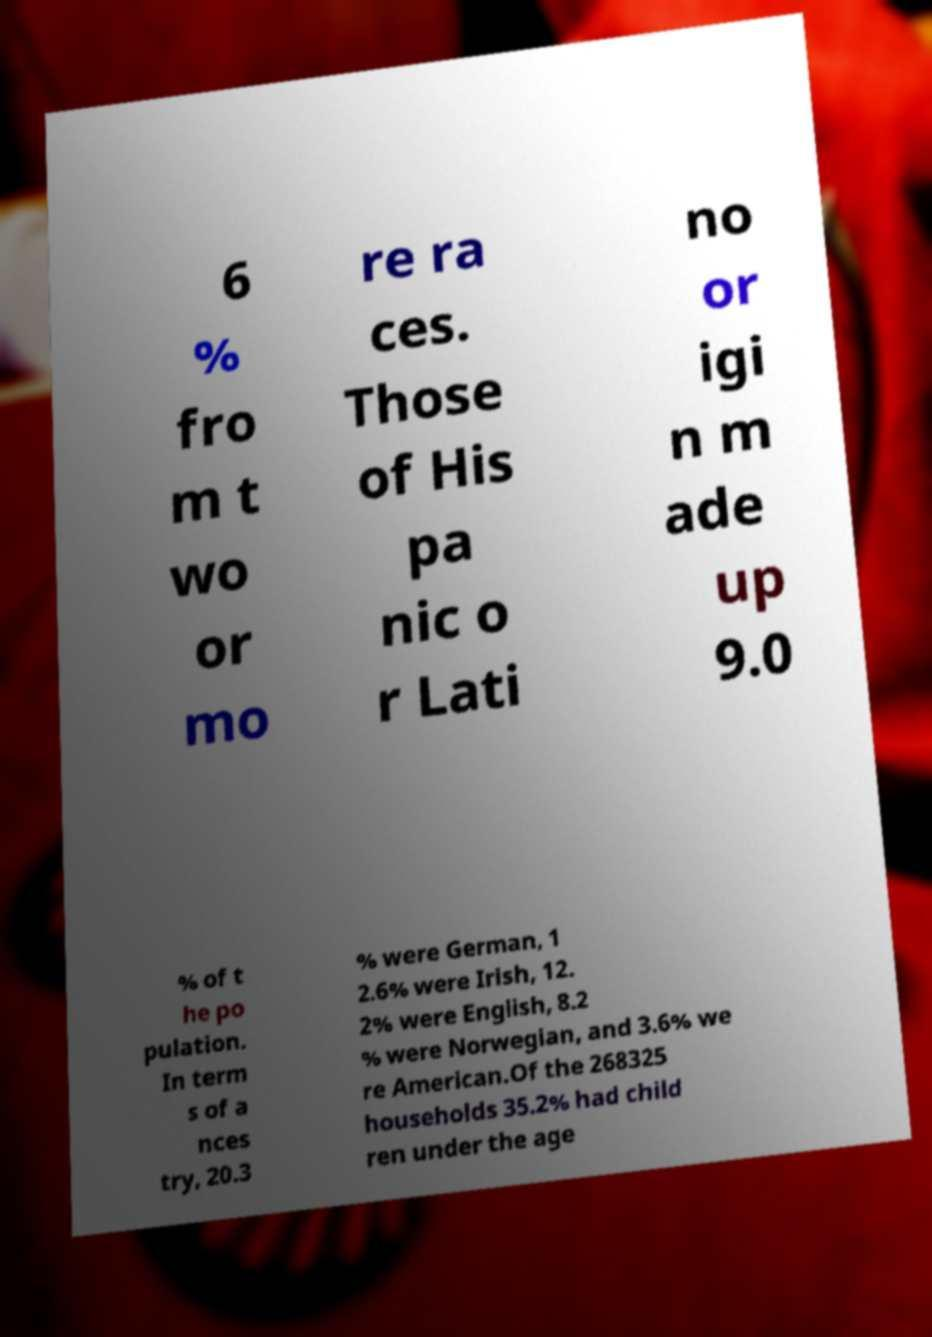I need the written content from this picture converted into text. Can you do that? 6 % fro m t wo or mo re ra ces. Those of His pa nic o r Lati no or igi n m ade up 9.0 % of t he po pulation. In term s of a nces try, 20.3 % were German, 1 2.6% were Irish, 12. 2% were English, 8.2 % were Norwegian, and 3.6% we re American.Of the 268325 households 35.2% had child ren under the age 